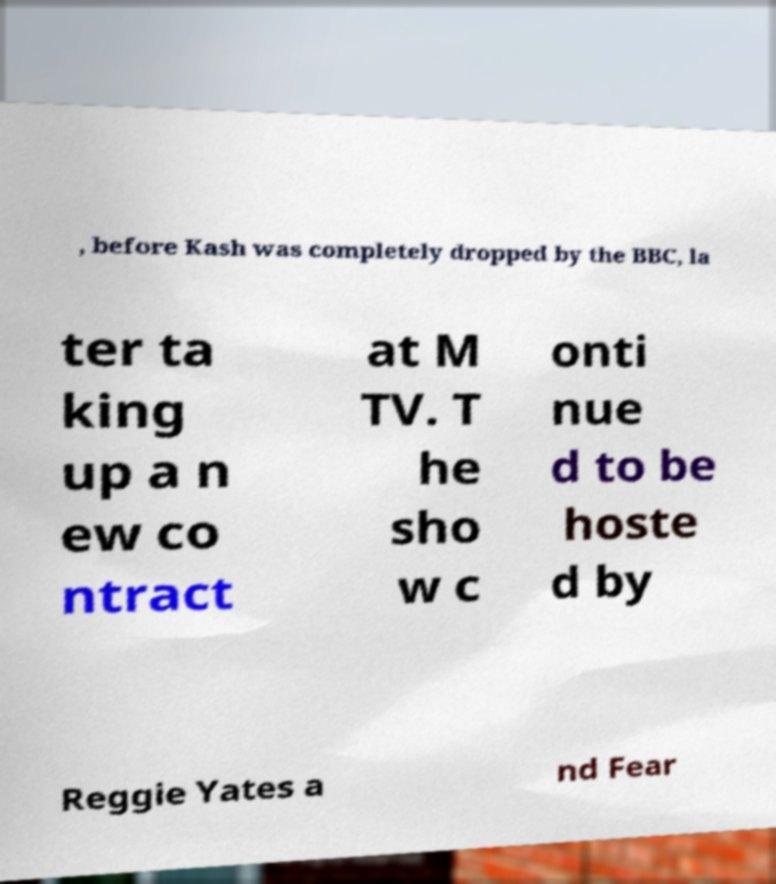Please read and relay the text visible in this image. What does it say? , before Kash was completely dropped by the BBC, la ter ta king up a n ew co ntract at M TV. T he sho w c onti nue d to be hoste d by Reggie Yates a nd Fear 